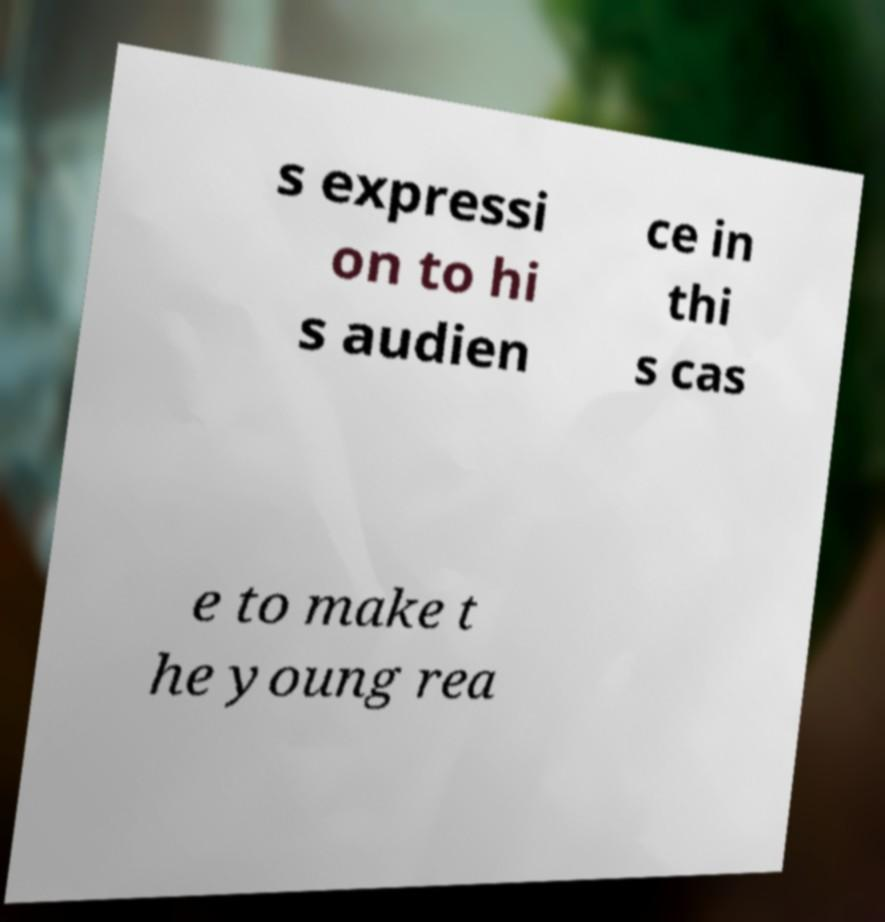Please read and relay the text visible in this image. What does it say? s expressi on to hi s audien ce in thi s cas e to make t he young rea 